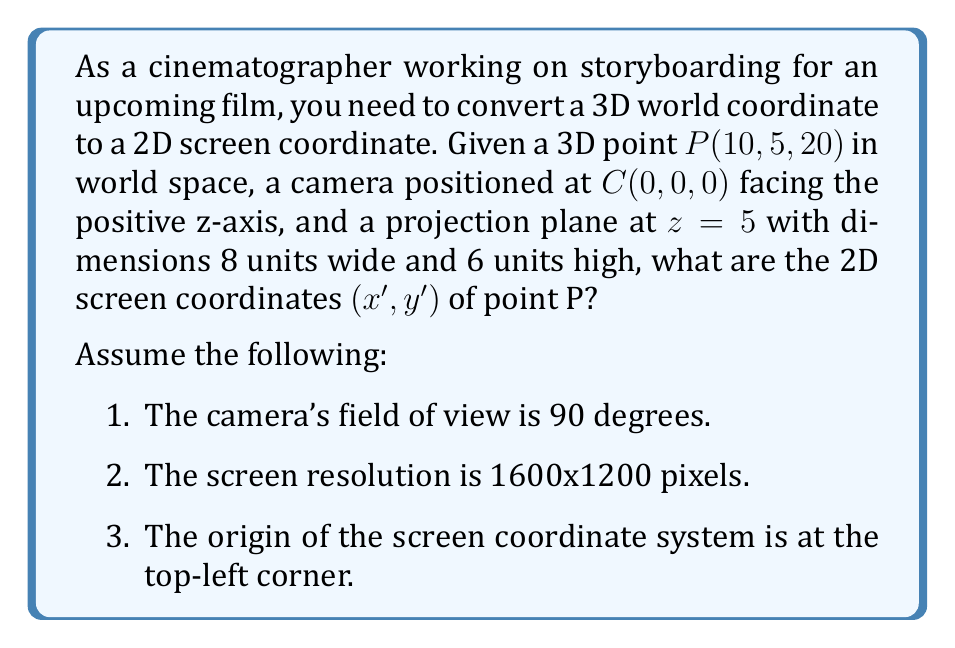Help me with this question. To solve this problem, we'll follow these steps:

1. Project the 3D point onto the projection plane:
   The projection plane is at $z=5$, so we need to scale our point accordingly:
   $$t = \frac{5}{20} = 0.25$$
   $$x' = 10 * 0.25 = 2.5$$
   $$y' = 5 * 0.25 = 1.25$$

2. Convert the projected coordinates to normalized device coordinates (NDC):
   The projection plane is 8 units wide and 6 units high, centered at (0, 0, 5).
   $$x_{NDC} = \frac{2.5}{4} = 0.625$$
   $$y_{NDC} = \frac{1.25}{3} = 0.4167$$

3. Convert NDC to screen coordinates:
   Screen width = 1600 pixels, height = 1200 pixels
   $$x_{screen} = (x_{NDC} + 1) * \frac{1600}{2} = (0.625 + 1) * 800 = 1300$$
   $$y_{screen} = (1 - y_{NDC}) * \frac{1200}{2} = (1 - 0.4167) * 600 = 350$$

[asy]
import geometry;

size(200);
draw((0,0)--(1600,0)--(1600,1200)--(0,1200)--cycle);
dot((1300,350), red);
label("P'(1300, 350)", (1300,350), NE, red);
label("(0,0)", (0,0), SW);
label("(1600,1200)", (1600,1200), NE);
[/asy]
Answer: The 2D screen coordinates of point P are approximately $(1300, 350)$ pixels. 